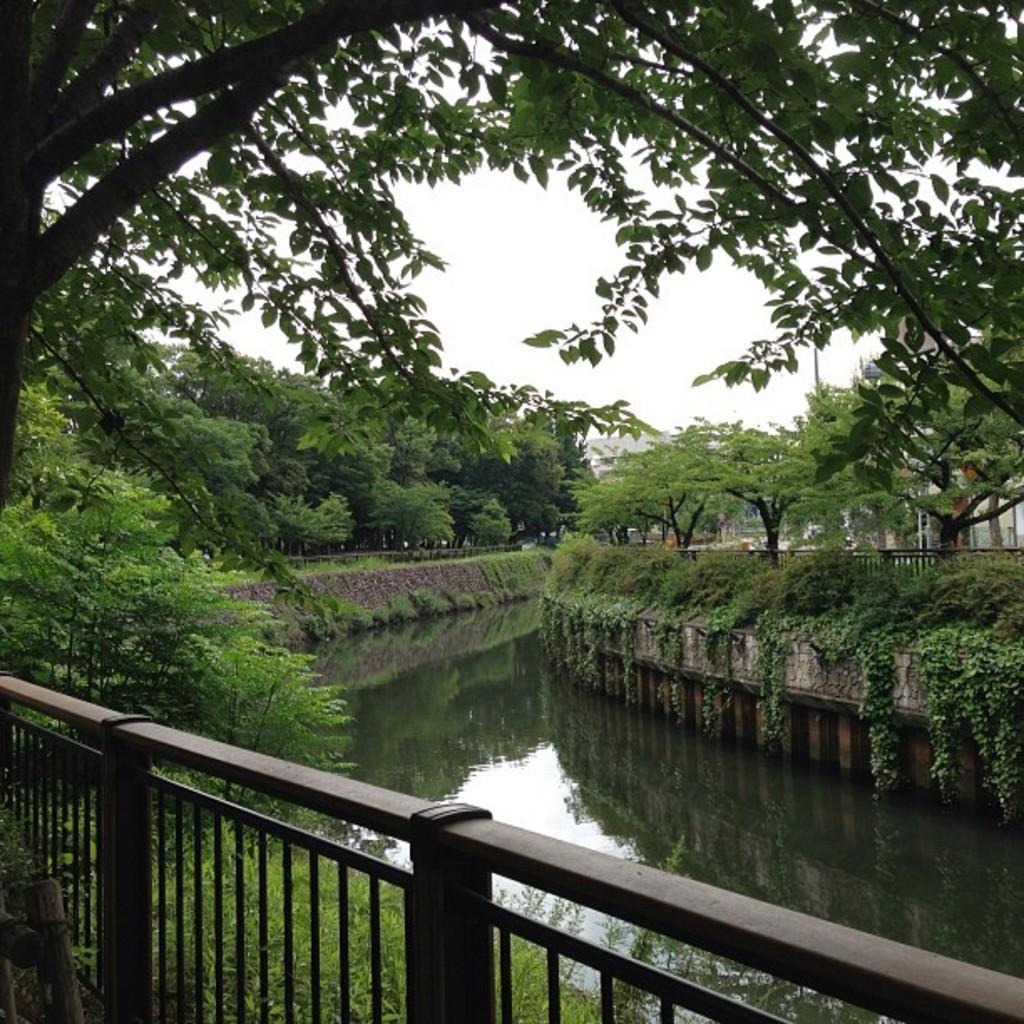How would you summarize this image in a sentence or two? We can see fence,grass and water. Background we can see trees,plants and sky. 